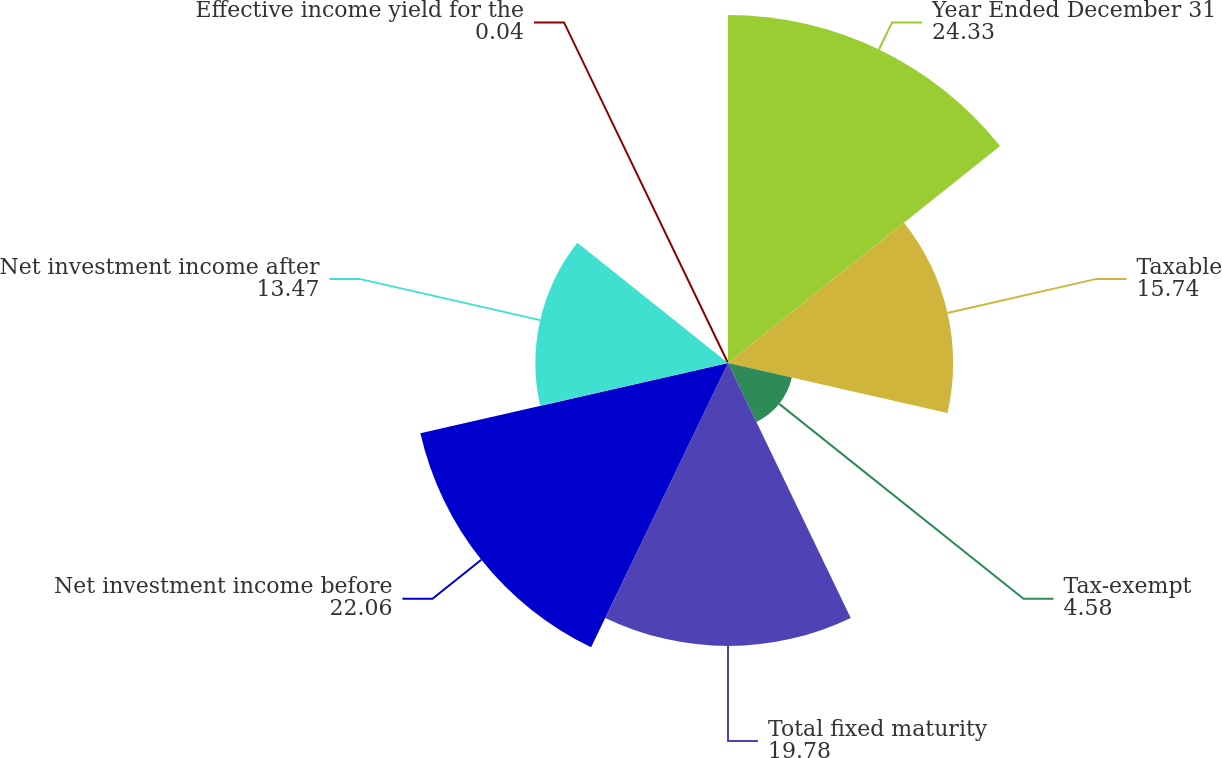Convert chart. <chart><loc_0><loc_0><loc_500><loc_500><pie_chart><fcel>Year Ended December 31<fcel>Taxable<fcel>Tax-exempt<fcel>Total fixed maturity<fcel>Net investment income before<fcel>Net investment income after<fcel>Effective income yield for the<nl><fcel>24.33%<fcel>15.74%<fcel>4.58%<fcel>19.78%<fcel>22.06%<fcel>13.47%<fcel>0.04%<nl></chart> 